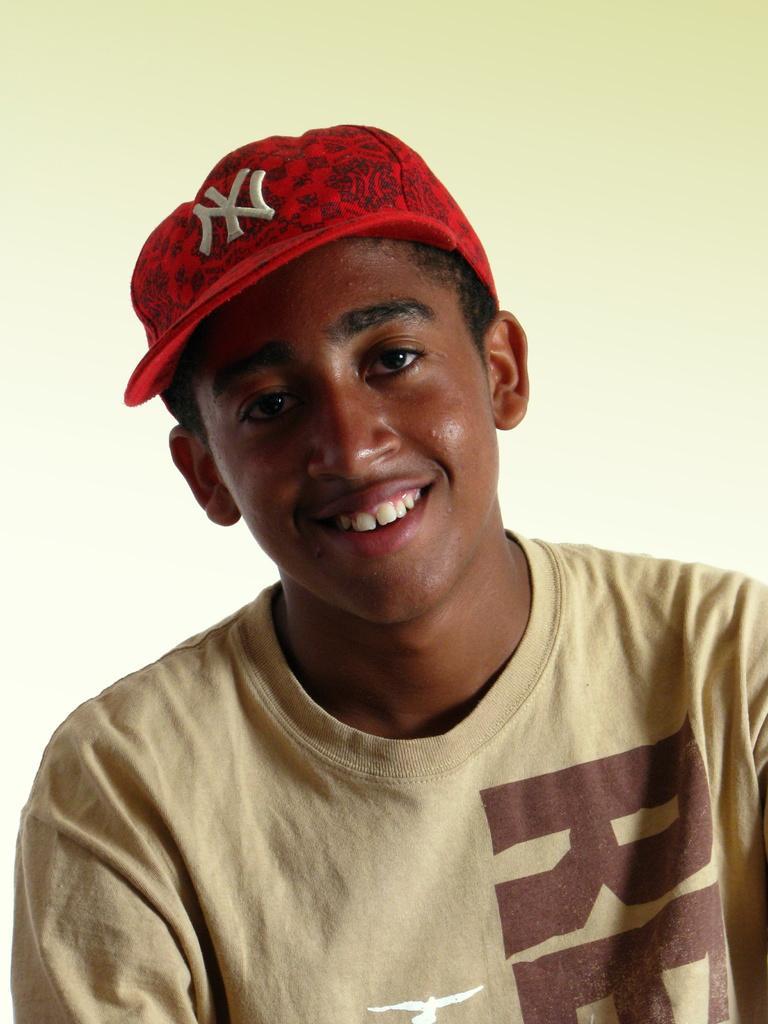Could you give a brief overview of what you see in this image? In this image, we can see a person wearing the cap. We can also see the background. 